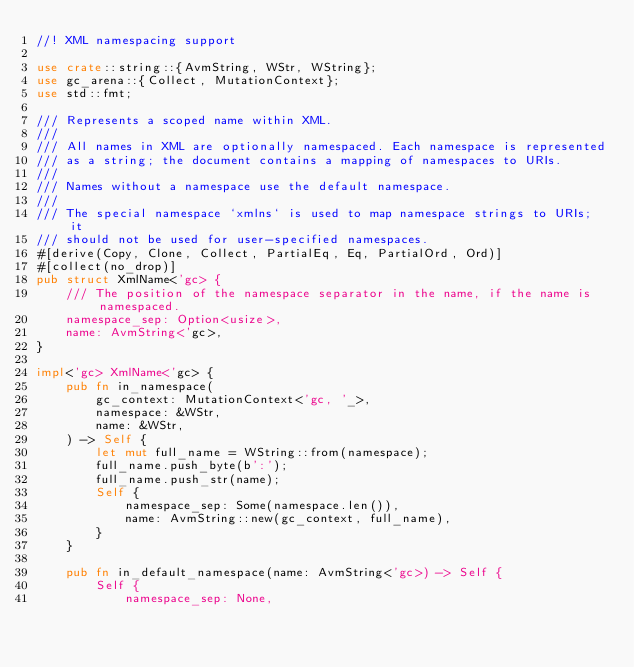<code> <loc_0><loc_0><loc_500><loc_500><_Rust_>//! XML namespacing support

use crate::string::{AvmString, WStr, WString};
use gc_arena::{Collect, MutationContext};
use std::fmt;

/// Represents a scoped name within XML.
///
/// All names in XML are optionally namespaced. Each namespace is represented
/// as a string; the document contains a mapping of namespaces to URIs.
///
/// Names without a namespace use the default namespace.
///
/// The special namespace `xmlns` is used to map namespace strings to URIs; it
/// should not be used for user-specified namespaces.
#[derive(Copy, Clone, Collect, PartialEq, Eq, PartialOrd, Ord)]
#[collect(no_drop)]
pub struct XmlName<'gc> {
    /// The position of the namespace separator in the name, if the name is namespaced.
    namespace_sep: Option<usize>,
    name: AvmString<'gc>,
}

impl<'gc> XmlName<'gc> {
    pub fn in_namespace(
        gc_context: MutationContext<'gc, '_>,
        namespace: &WStr,
        name: &WStr,
    ) -> Self {
        let mut full_name = WString::from(namespace);
        full_name.push_byte(b':');
        full_name.push_str(name);
        Self {
            namespace_sep: Some(namespace.len()),
            name: AvmString::new(gc_context, full_name),
        }
    }

    pub fn in_default_namespace(name: AvmString<'gc>) -> Self {
        Self {
            namespace_sep: None,</code> 